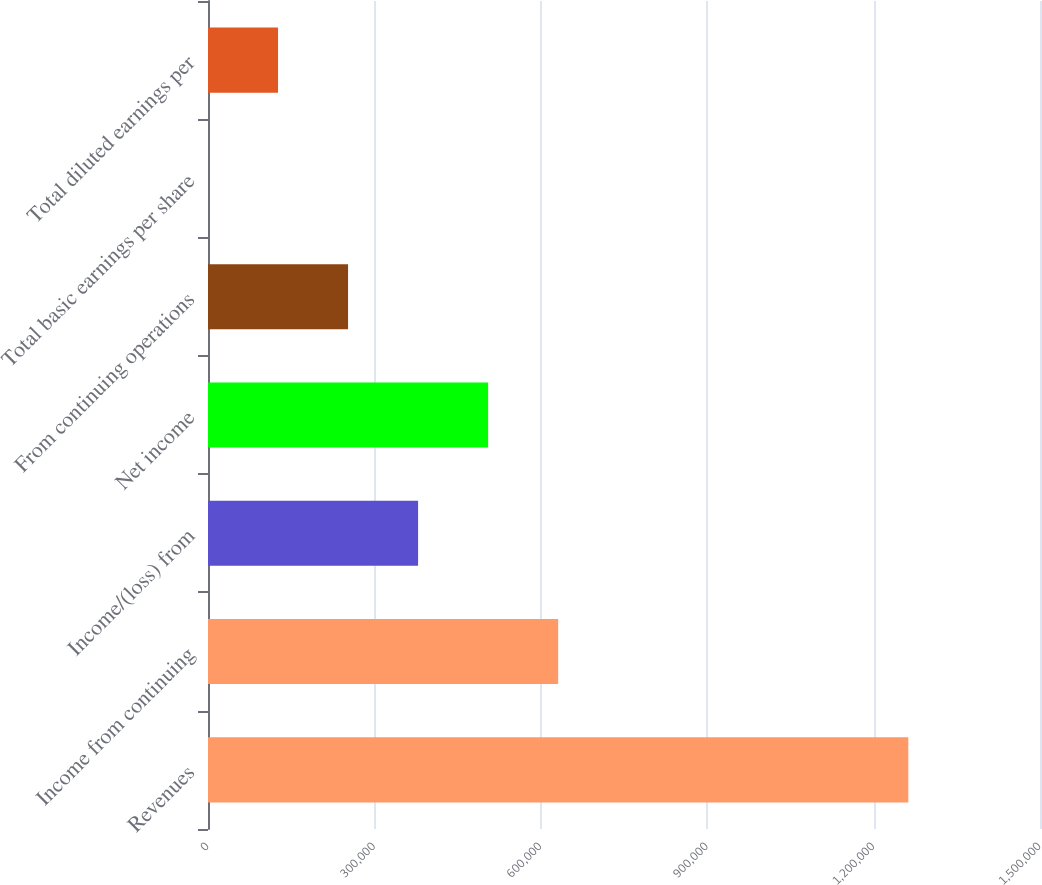<chart> <loc_0><loc_0><loc_500><loc_500><bar_chart><fcel>Revenues<fcel>Income from continuing<fcel>Income/(loss) from<fcel>Net income<fcel>From continuing operations<fcel>Total basic earnings per share<fcel>Total diluted earnings per<nl><fcel>1.26258e+06<fcel>631289<fcel>378774<fcel>505031<fcel>252516<fcel>1.07<fcel>126259<nl></chart> 